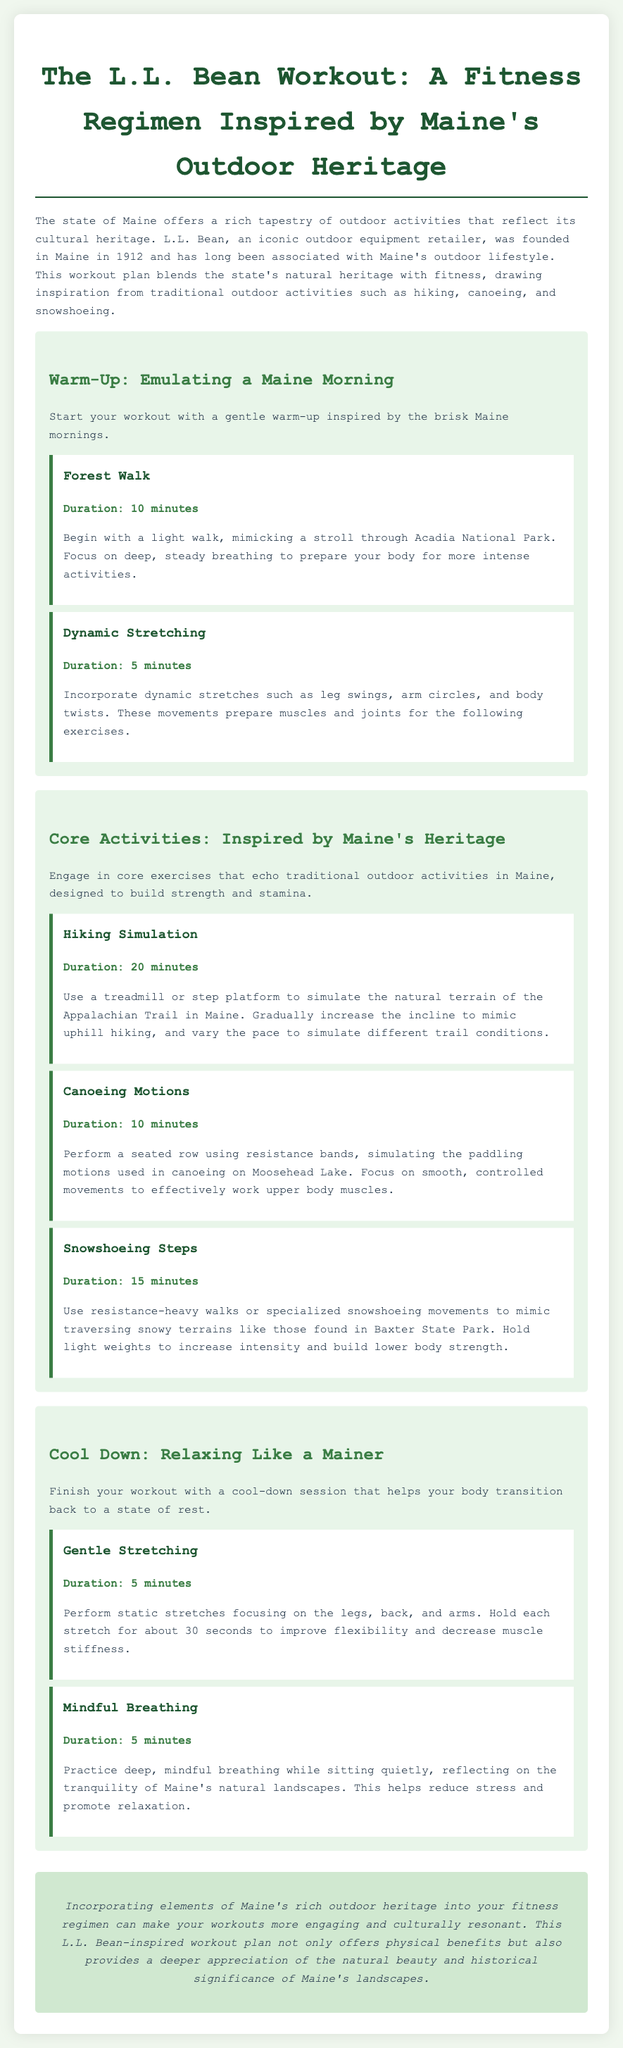what is the title of the workout plan? The title of the workout plan is the main heading at the top of the document.
Answer: The L.L. Bean Workout: A Fitness Regimen Inspired by Maine's Outdoor Heritage how long does the Hiking Simulation activity last? The duration of the Hiking Simulation activity is listed in the core activities section.
Answer: 20 minutes which outdoor activity is associated with Moosehead Lake? The document mentions a specific activity that relates to Moosehead Lake in the canoeing section.
Answer: Canoeing what is the first warm-up activity listed? The first warm-up activity can be found in the warm-up section of the document.
Answer: Forest Walk what type of stretches are included in the cool-down session? The cool-down session highlights a specific type of movements that are meant to relax the body.
Answer: Gentle Stretching how many core activities are detailed in the workout plan? The total number of core activities is counted from the core activities section.
Answer: Three what does the Mindful Breathing activity help to reduce? This activity's purpose is described in the cool-down section of the document.
Answer: Stress what year was L.L. Bean founded? The founding year of L.L. Bean is mentioned in the introductory paragraph.
Answer: 1912 